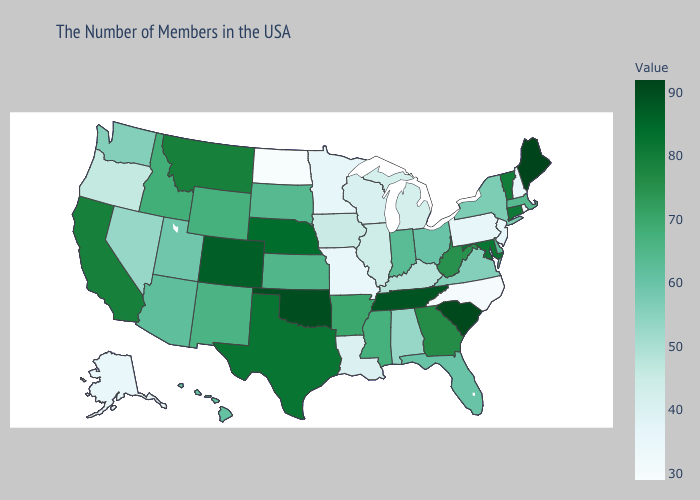Does New Hampshire have the highest value in the Northeast?
Give a very brief answer. No. Does Kansas have the highest value in the MidWest?
Answer briefly. No. Among the states that border Wisconsin , which have the lowest value?
Keep it brief. Minnesota. Among the states that border Virginia , which have the highest value?
Quick response, please. Tennessee. Among the states that border Michigan , does Indiana have the highest value?
Write a very short answer. Yes. Among the states that border Georgia , which have the lowest value?
Answer briefly. North Carolina. 